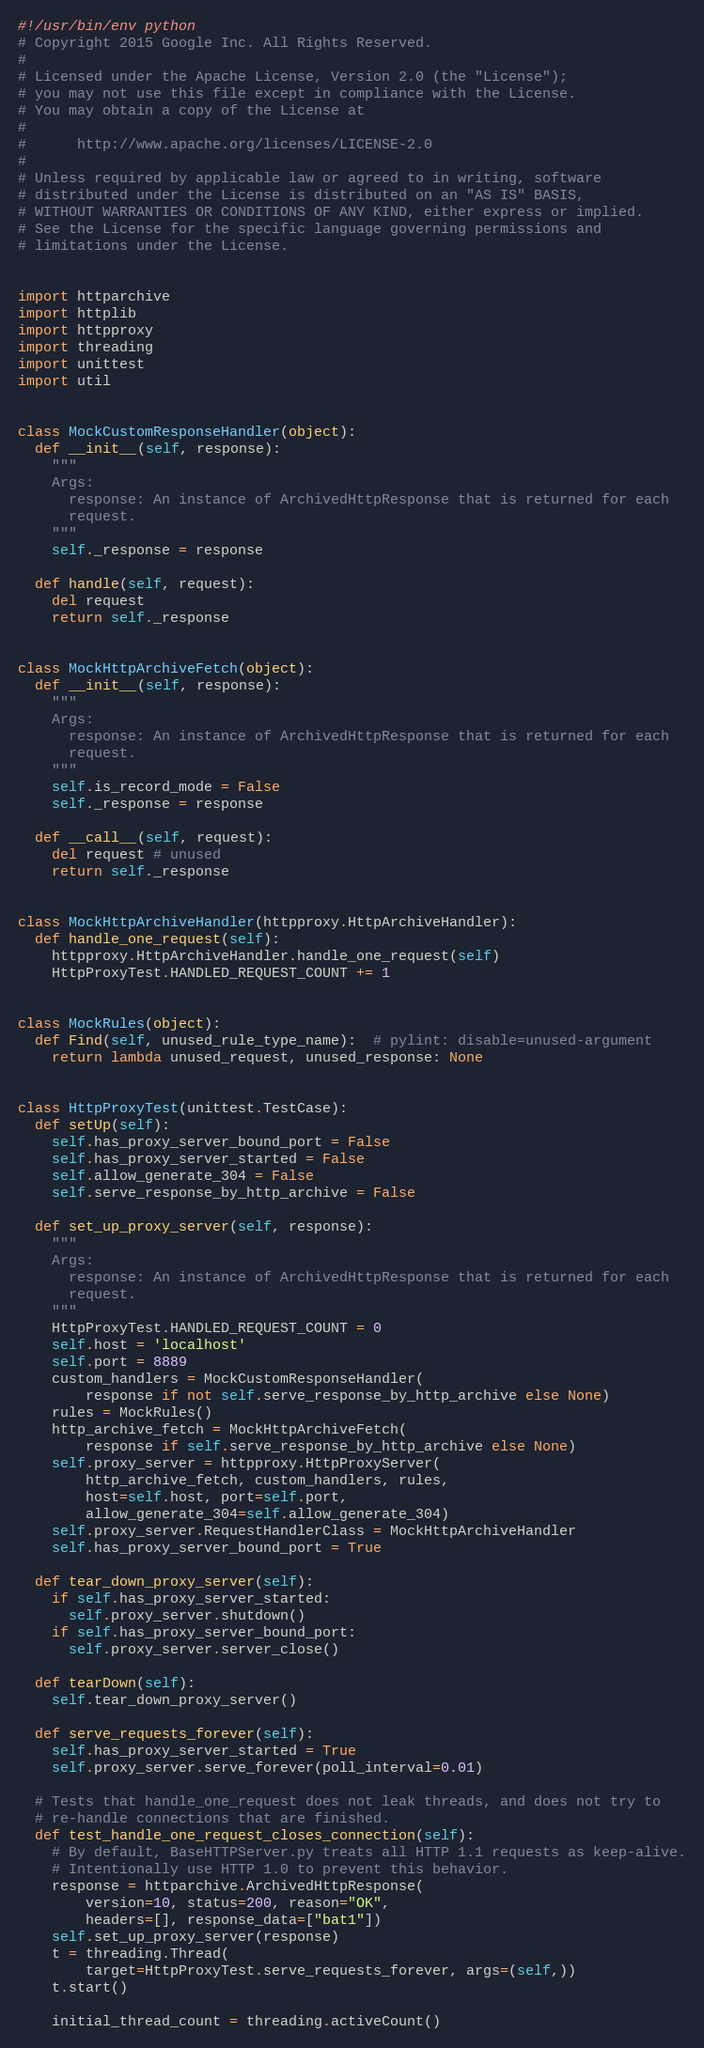Convert code to text. <code><loc_0><loc_0><loc_500><loc_500><_Python_>#!/usr/bin/env python
# Copyright 2015 Google Inc. All Rights Reserved.
#
# Licensed under the Apache License, Version 2.0 (the "License");
# you may not use this file except in compliance with the License.
# You may obtain a copy of the License at
#
#      http://www.apache.org/licenses/LICENSE-2.0
#
# Unless required by applicable law or agreed to in writing, software
# distributed under the License is distributed on an "AS IS" BASIS,
# WITHOUT WARRANTIES OR CONDITIONS OF ANY KIND, either express or implied.
# See the License for the specific language governing permissions and
# limitations under the License.


import httparchive
import httplib
import httpproxy
import threading
import unittest
import util


class MockCustomResponseHandler(object):
  def __init__(self, response):
    """
    Args:
      response: An instance of ArchivedHttpResponse that is returned for each
      request.
    """
    self._response = response

  def handle(self, request):
    del request
    return self._response


class MockHttpArchiveFetch(object):
  def __init__(self, response):
    """
    Args:
      response: An instance of ArchivedHttpResponse that is returned for each
      request.
    """
    self.is_record_mode = False
    self._response = response

  def __call__(self, request):
    del request # unused
    return self._response


class MockHttpArchiveHandler(httpproxy.HttpArchiveHandler):
  def handle_one_request(self):
    httpproxy.HttpArchiveHandler.handle_one_request(self)
    HttpProxyTest.HANDLED_REQUEST_COUNT += 1


class MockRules(object):
  def Find(self, unused_rule_type_name):  # pylint: disable=unused-argument
    return lambda unused_request, unused_response: None


class HttpProxyTest(unittest.TestCase):
  def setUp(self):
    self.has_proxy_server_bound_port = False
    self.has_proxy_server_started = False
    self.allow_generate_304 = False
    self.serve_response_by_http_archive = False

  def set_up_proxy_server(self, response):
    """
    Args:
      response: An instance of ArchivedHttpResponse that is returned for each
      request.
    """
    HttpProxyTest.HANDLED_REQUEST_COUNT = 0
    self.host = 'localhost'
    self.port = 8889
    custom_handlers = MockCustomResponseHandler(
        response if not self.serve_response_by_http_archive else None)
    rules = MockRules()
    http_archive_fetch = MockHttpArchiveFetch(
        response if self.serve_response_by_http_archive else None)
    self.proxy_server = httpproxy.HttpProxyServer(
        http_archive_fetch, custom_handlers, rules,
        host=self.host, port=self.port,
        allow_generate_304=self.allow_generate_304)
    self.proxy_server.RequestHandlerClass = MockHttpArchiveHandler
    self.has_proxy_server_bound_port = True

  def tear_down_proxy_server(self):
    if self.has_proxy_server_started:
      self.proxy_server.shutdown()
    if self.has_proxy_server_bound_port:
      self.proxy_server.server_close()

  def tearDown(self):
    self.tear_down_proxy_server()

  def serve_requests_forever(self):
    self.has_proxy_server_started = True
    self.proxy_server.serve_forever(poll_interval=0.01)

  # Tests that handle_one_request does not leak threads, and does not try to
  # re-handle connections that are finished.
  def test_handle_one_request_closes_connection(self):
    # By default, BaseHTTPServer.py treats all HTTP 1.1 requests as keep-alive.
    # Intentionally use HTTP 1.0 to prevent this behavior.
    response = httparchive.ArchivedHttpResponse(
        version=10, status=200, reason="OK",
        headers=[], response_data=["bat1"])
    self.set_up_proxy_server(response)
    t = threading.Thread(
        target=HttpProxyTest.serve_requests_forever, args=(self,))
    t.start()

    initial_thread_count = threading.activeCount()
</code> 